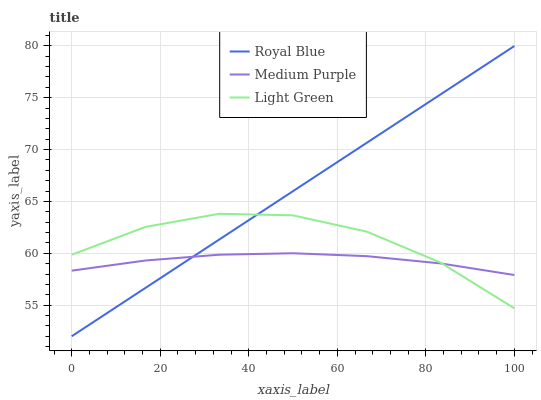Does Medium Purple have the minimum area under the curve?
Answer yes or no. Yes. Does Royal Blue have the maximum area under the curve?
Answer yes or no. Yes. Does Light Green have the minimum area under the curve?
Answer yes or no. No. Does Light Green have the maximum area under the curve?
Answer yes or no. No. Is Royal Blue the smoothest?
Answer yes or no. Yes. Is Light Green the roughest?
Answer yes or no. Yes. Is Light Green the smoothest?
Answer yes or no. No. Is Royal Blue the roughest?
Answer yes or no. No. Does Royal Blue have the lowest value?
Answer yes or no. Yes. Does Light Green have the lowest value?
Answer yes or no. No. Does Royal Blue have the highest value?
Answer yes or no. Yes. Does Light Green have the highest value?
Answer yes or no. No. Does Medium Purple intersect Light Green?
Answer yes or no. Yes. Is Medium Purple less than Light Green?
Answer yes or no. No. Is Medium Purple greater than Light Green?
Answer yes or no. No. 